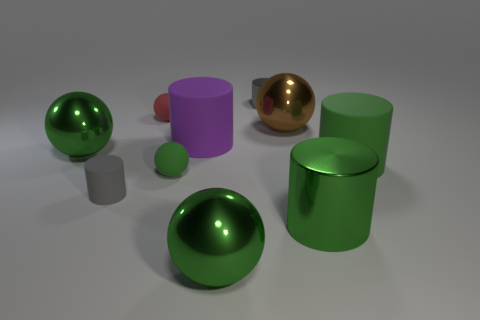Subtract all gray cylinders. How many green spheres are left? 3 Subtract all purple rubber cylinders. How many cylinders are left? 4 Subtract all red spheres. How many spheres are left? 4 Subtract all purple balls. Subtract all yellow cylinders. How many balls are left? 5 Subtract 1 brown spheres. How many objects are left? 9 Subtract all green objects. Subtract all small green spheres. How many objects are left? 4 Add 2 big things. How many big things are left? 8 Add 7 small gray metallic objects. How many small gray metallic objects exist? 8 